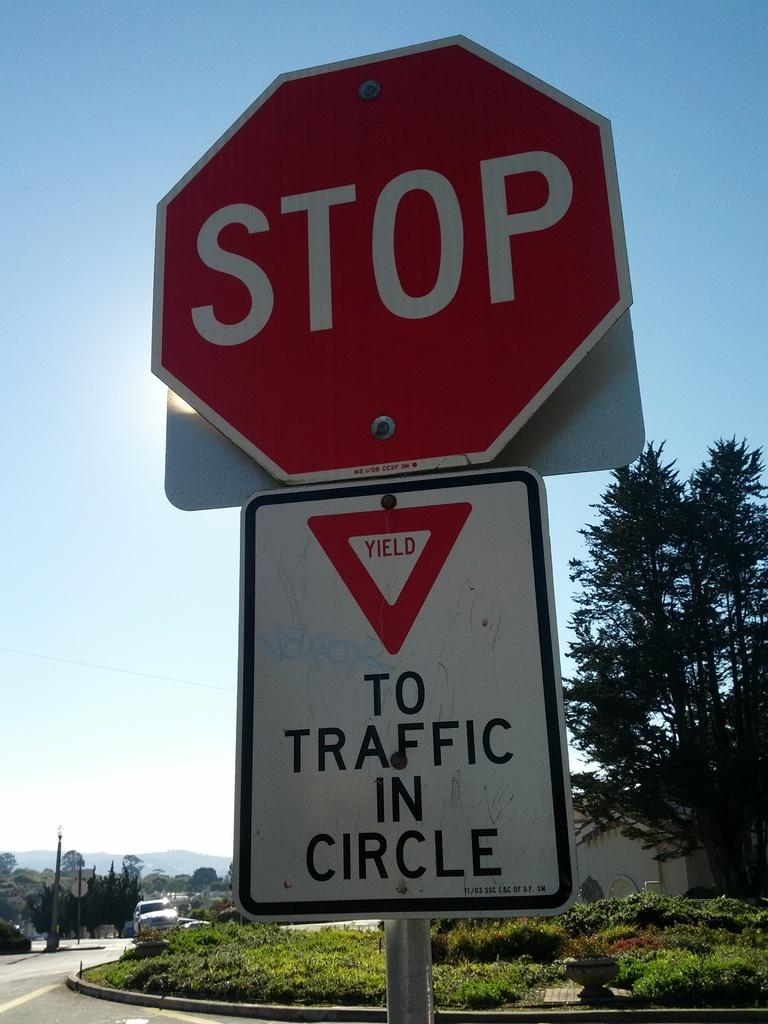<image>
Give a short and clear explanation of the subsequent image. The white sign below the red one warns drivers to yield to particular traffic. 